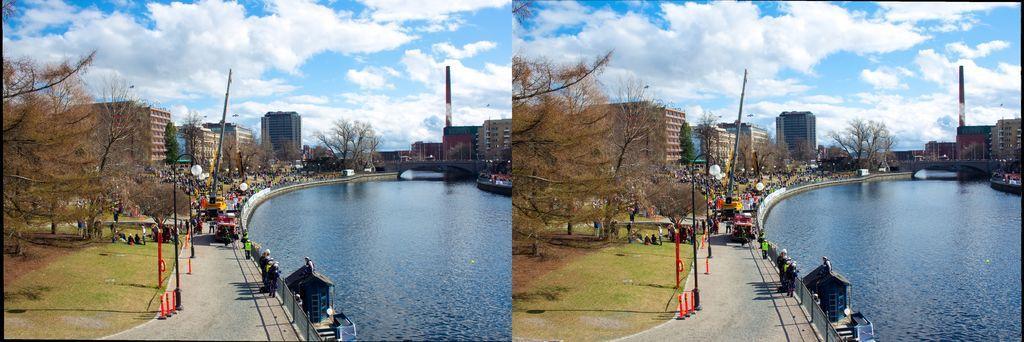Please provide a concise description of this image. This is a collage image. There is water to the right side of the image. There are trees. In the background of the image there are buildings. There is grass. There is a fencing. 